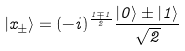<formula> <loc_0><loc_0><loc_500><loc_500>| x _ { \pm } \rangle = ( - i ) ^ { \frac { 1 \mp 1 } { 2 } } \frac { | 0 \rangle \pm | 1 \rangle } { \sqrt { 2 } }</formula> 